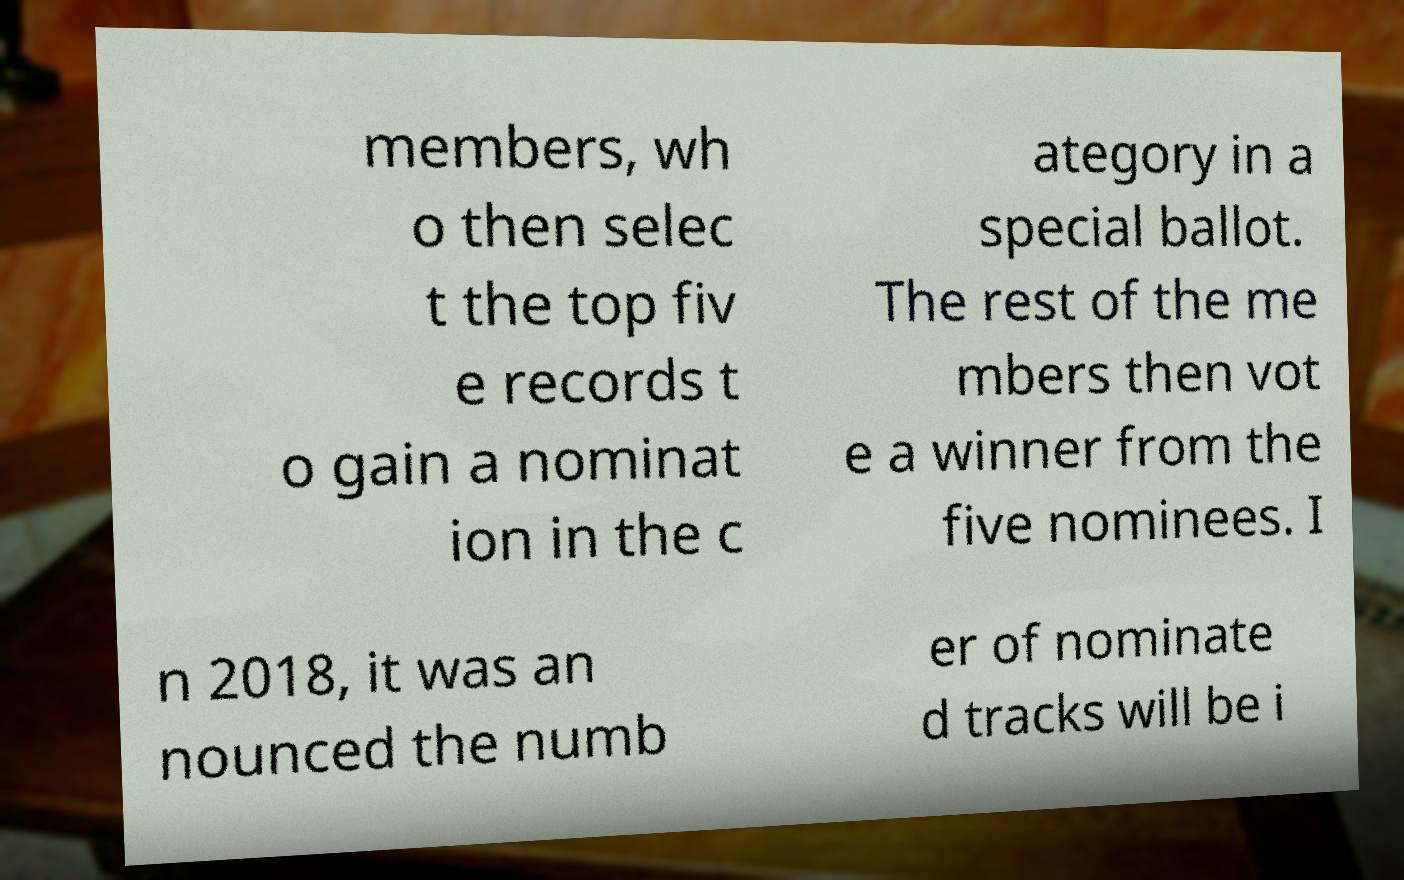Can you accurately transcribe the text from the provided image for me? members, wh o then selec t the top fiv e records t o gain a nominat ion in the c ategory in a special ballot. The rest of the me mbers then vot e a winner from the five nominees. I n 2018, it was an nounced the numb er of nominate d tracks will be i 